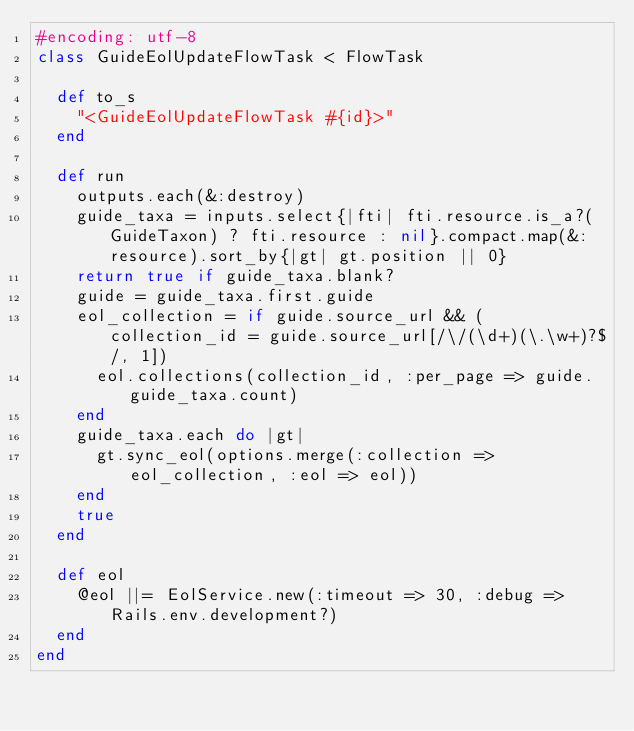<code> <loc_0><loc_0><loc_500><loc_500><_Ruby_>#encoding: utf-8
class GuideEolUpdateFlowTask < FlowTask

  def to_s
    "<GuideEolUpdateFlowTask #{id}>"
  end

  def run
    outputs.each(&:destroy)
    guide_taxa = inputs.select{|fti| fti.resource.is_a?(GuideTaxon) ? fti.resource : nil}.compact.map(&:resource).sort_by{|gt| gt.position || 0}
    return true if guide_taxa.blank?
    guide = guide_taxa.first.guide
    eol_collection = if guide.source_url && (collection_id = guide.source_url[/\/(\d+)(\.\w+)?$/, 1])
      eol.collections(collection_id, :per_page => guide.guide_taxa.count)
    end
    guide_taxa.each do |gt|
      gt.sync_eol(options.merge(:collection => eol_collection, :eol => eol))
    end
    true
  end

  def eol
    @eol ||= EolService.new(:timeout => 30, :debug => Rails.env.development?)
  end
end
</code> 